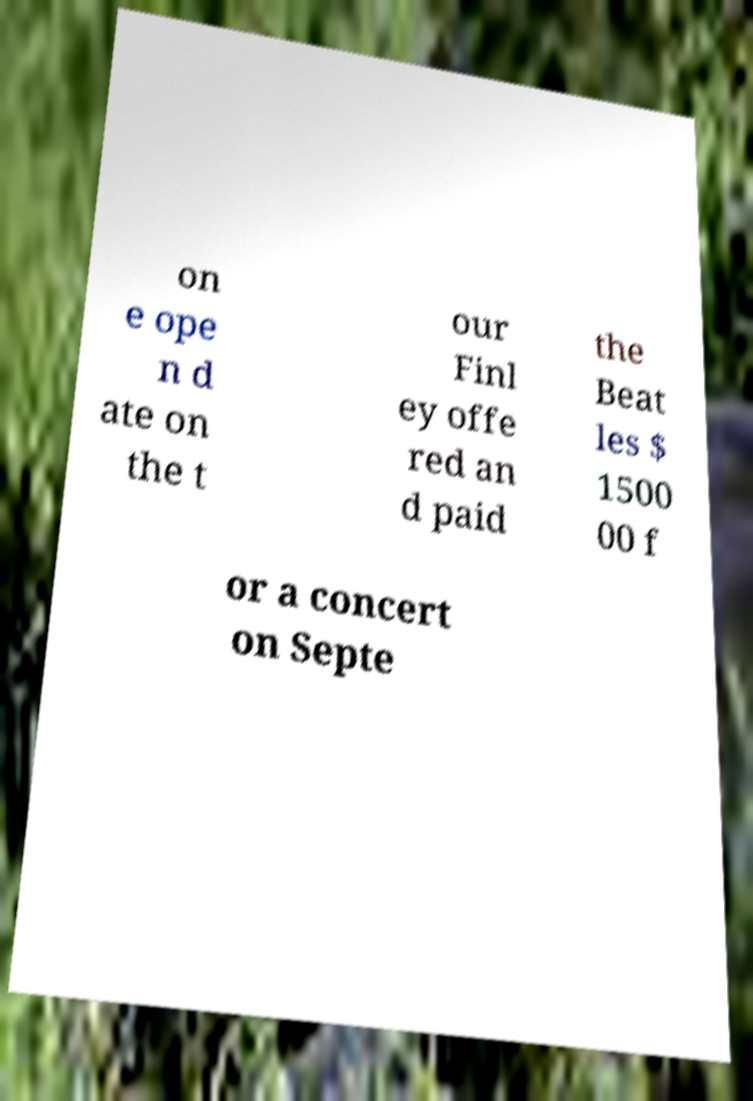There's text embedded in this image that I need extracted. Can you transcribe it verbatim? on e ope n d ate on the t our Finl ey offe red an d paid the Beat les $ 1500 00 f or a concert on Septe 